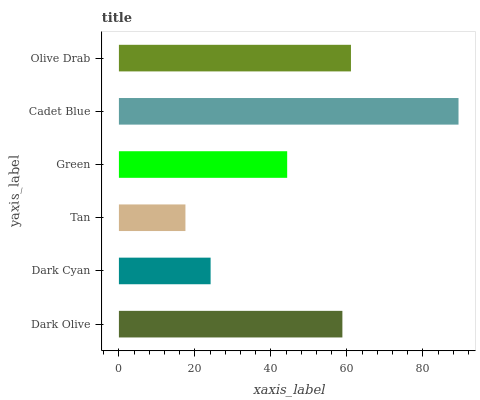Is Tan the minimum?
Answer yes or no. Yes. Is Cadet Blue the maximum?
Answer yes or no. Yes. Is Dark Cyan the minimum?
Answer yes or no. No. Is Dark Cyan the maximum?
Answer yes or no. No. Is Dark Olive greater than Dark Cyan?
Answer yes or no. Yes. Is Dark Cyan less than Dark Olive?
Answer yes or no. Yes. Is Dark Cyan greater than Dark Olive?
Answer yes or no. No. Is Dark Olive less than Dark Cyan?
Answer yes or no. No. Is Dark Olive the high median?
Answer yes or no. Yes. Is Green the low median?
Answer yes or no. Yes. Is Cadet Blue the high median?
Answer yes or no. No. Is Tan the low median?
Answer yes or no. No. 